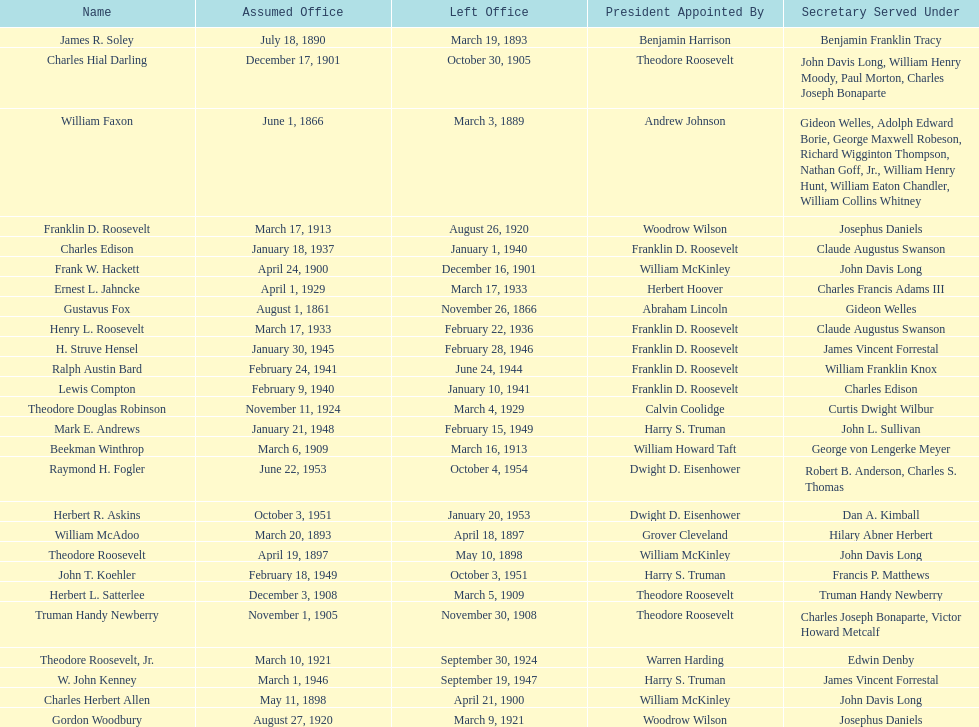When did raymond h. fogler leave the office of assistant secretary of the navy? October 4, 1954. 